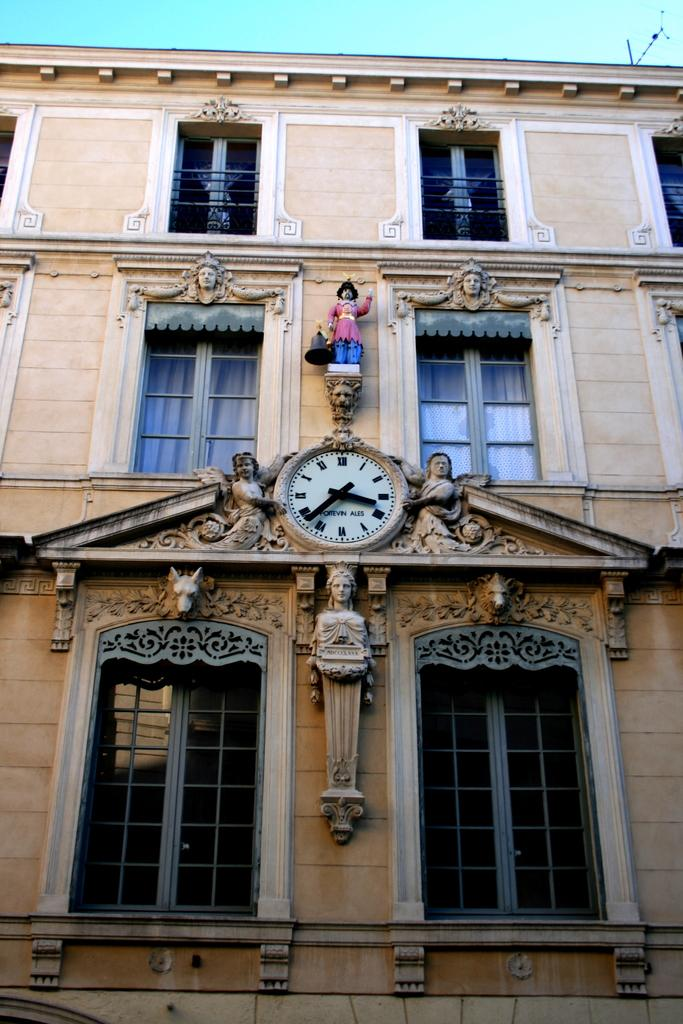<image>
Offer a succinct explanation of the picture presented. The clock on the building shows the time as 3:38. 